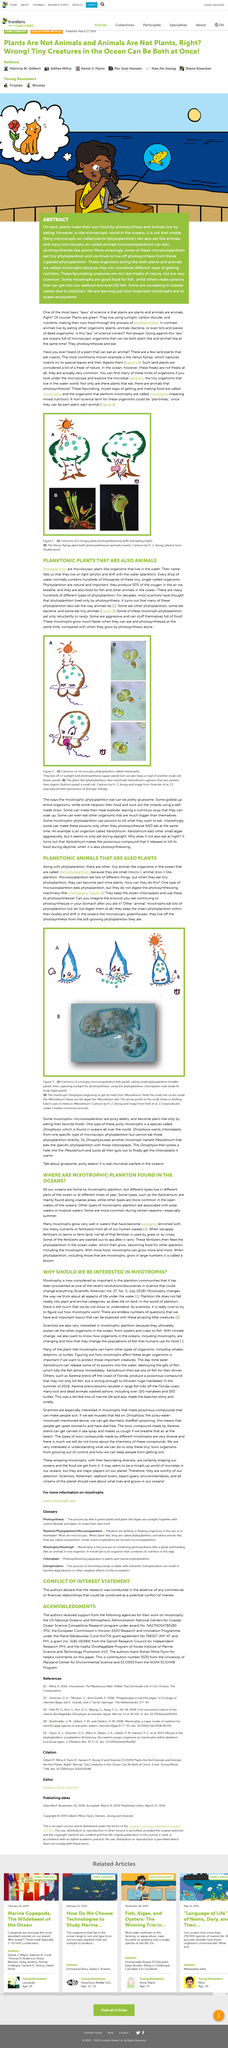List a handful of essential elements in this visual. The article in question is titled "PLANKTONIC PLANTS THAT ARE ALSO ANIMALS. The process by which plants produce their own food is known as photosynthesis. Yes, plant-like mixotrophs can harm turtles. Mixotrophs are a type of organism that engage in mixotrophy, which is the coexistence of heterotrophic and autotrophic nutritional strategies. These organisms are able to obtain nutrients from both external sources, such as photosynthesis or predation, and internal sources, such as storage organisms or intracellular digestion. The ability to switch between different nutritional strategies allows mixotrophs to adapt to a wide range of environments and obtain energy in a flexible and versatile manner. Microzooplankton is a small, animal-like organism that exists alongside phytoplankton in the ocean. It is a crucial component of the ocean ecosystem, playing a significant role in the food chain and the overall health of the marine environment. 